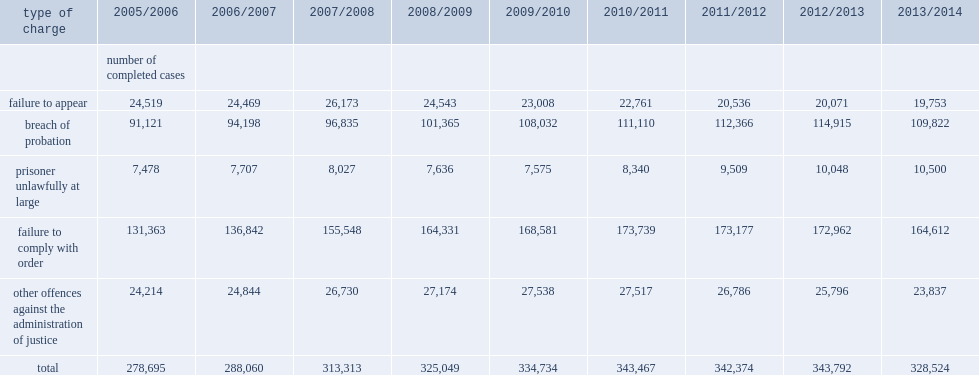In completed adult criminal court cases where an administration of justice offence represented one or more of the charges,which type of charges were most frequently finalized by the courts in 2013/2014? Failure to comply with order. In 2013/2014,what is the percentage of completed adult criminal court cases where an administration of justice offence represented one or more of the charges were breach of probation? 0.334289. Between 2005/2006 and 2013/2014, how much did cases involving the relatively low-volume charge of prisoner unlawfully at large grow? 0.404119. Between 2005/2006 and 2013/2014,how much did cases where failure to comply with an order were among the charges grow? 0.253108. Between 2005/2006 and 2013/2014,how much did cases charged of breach of probation grow? 0.205233. Between 2005/2006 and 2013/2014,how much did instances of failure change? -0.19438. 